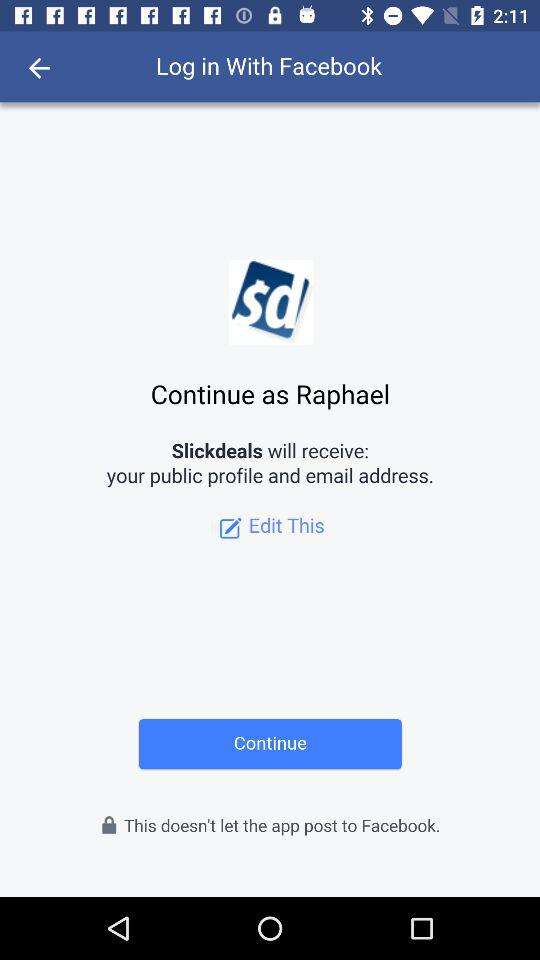Through what application is the person logging in? The person is logging in with "Facebook". 